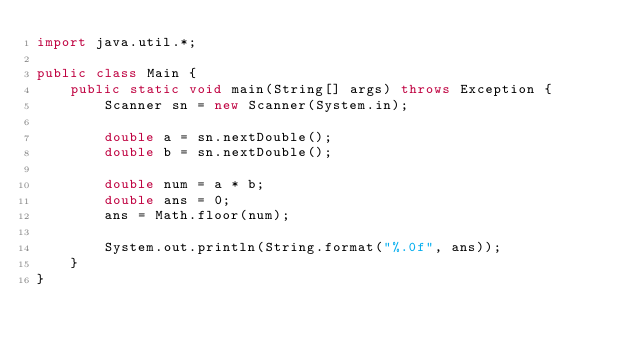Convert code to text. <code><loc_0><loc_0><loc_500><loc_500><_Java_>import java.util.*;

public class Main {
    public static void main(String[] args) throws Exception {
        Scanner sn = new Scanner(System.in);
        
        double a = sn.nextDouble();
        double b = sn.nextDouble();
        
        double num = a * b;
        double ans = 0;
        ans = Math.floor(num);
        
        System.out.println(String.format("%.0f", ans));
    }
}
</code> 